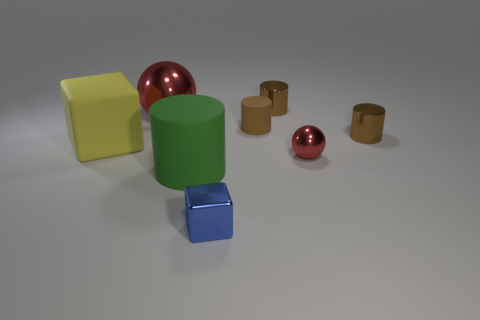There is a yellow object that is the same shape as the tiny blue metal object; what size is it?
Make the answer very short. Large. What number of other rubber balls have the same color as the small sphere?
Give a very brief answer. 0. What is the color of the small ball that is made of the same material as the big red object?
Provide a short and direct response. Red. Are there any metal things that have the same size as the green cylinder?
Your answer should be very brief. Yes. Is the number of cylinders in front of the big yellow object greater than the number of large green matte cylinders to the right of the tiny blue block?
Ensure brevity in your answer.  Yes. Is the material of the red ball that is in front of the big yellow cube the same as the thing that is behind the big red thing?
Keep it short and to the point. Yes. What shape is the metallic thing that is the same size as the green cylinder?
Your answer should be compact. Sphere. Are there any other big objects of the same shape as the large green object?
Ensure brevity in your answer.  No. Is the color of the metallic cylinder that is behind the small matte thing the same as the small cylinder on the right side of the small red sphere?
Ensure brevity in your answer.  Yes. Are there any blue metal things on the left side of the large sphere?
Keep it short and to the point. No. 